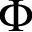Convert formula to latex. <formula><loc_0><loc_0><loc_500><loc_500>\Phi</formula> 